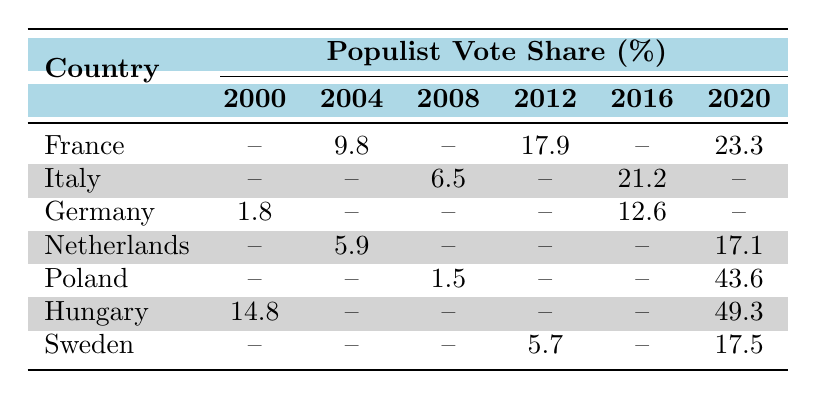What was the populist vote share in France in 2012? The populist vote share for France in 2012 is directly listed in the table as 17.9%.
Answer: 17.9% Which country had the highest populist vote share in 2020? According to the table, Poland had the highest populist vote share in 2020 at 43.6%.
Answer: Poland What is the average populist vote share in Italy from 2008 to 2016? The populist vote shares for Italy are 6.5% (2008) and 21.2% (2016). We calculate the average as (6.5 + 21.2) / 2 = 13.85%.
Answer: 13.85% In which year did Germany record a populist vote share of 12.6%? The table indicates that Germany recorded a populist vote share of 12.6% in 2016.
Answer: 2016 Did the populist vote share increase in France from 2004 to 2020? By comparing the populist vote shares, we see that it increased from 9.8% in 2004 to 23.3% in 2020, thus confirming the increase.
Answer: Yes How much did the populist vote share in Hungary increase from 2000 to 2020? In 2000, Hungary's populist vote share was 14.8%, increasing to 49.3% in 2020. We find the increase by subtracting: 49.3 - 14.8 = 34.5%.
Answer: 34.5% Which country showed the lowest populist vote share in 2008? Reviewing the table, Poland recorded the lowest populist vote share in 2008 at 1.5%.
Answer: Poland What was the difference in populist vote share between Sweden in 2012 and 2020? Sweden had a populist vote share of 5.7% in 2012 and 17.5% in 2020. The difference is: 17.5 - 5.7 = 11.8%.
Answer: 11.8% Is the turnout in Italy in 2008 higher than in Hungary in 2000? The turnout in Italy in 2008 was 80.5%, while Hungary's turnout in 2000 was 70.5%. Comparing the two shows that Italy's turnout was indeed higher.
Answer: Yes What percentage of the populist vote share did the mainstream left receive in Germany in 2016? According to the table, the mainstream left vote share in Germany for 2016 is 20.5%.
Answer: 20.5% How did the populist vote shares in the Netherlands compare between 2004 and 2020? The table shows that the populist vote share in the Netherlands was 5.9% in 2004 and 17.1% in 2020, indicating an increase.
Answer: Increased 